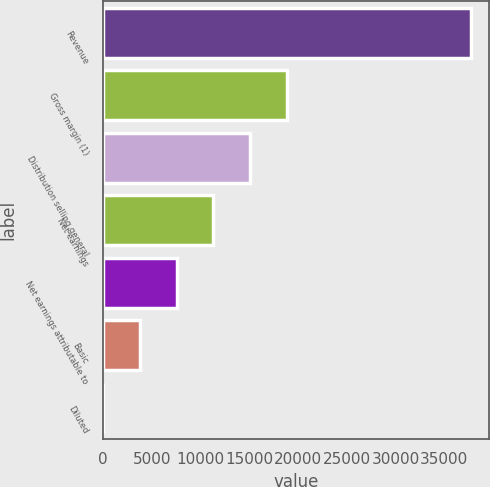Convert chart. <chart><loc_0><loc_0><loc_500><loc_500><bar_chart><fcel>Revenue<fcel>Gross margin (1)<fcel>Distribution selling general<fcel>Net earnings<fcel>Net earnings attributable to<fcel>Basic<fcel>Diluted<nl><fcel>37740<fcel>18870.5<fcel>15096.6<fcel>11322.7<fcel>7548.75<fcel>3774.84<fcel>0.93<nl></chart> 